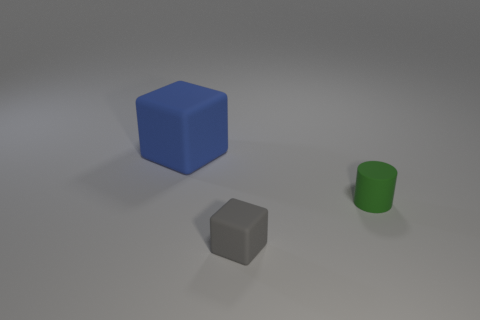Add 3 tiny gray things. How many objects exist? 6 Subtract all blocks. How many objects are left? 1 Add 2 large gray rubber cylinders. How many large gray rubber cylinders exist? 2 Subtract 1 gray blocks. How many objects are left? 2 Subtract all large blue objects. Subtract all small green objects. How many objects are left? 1 Add 1 green rubber objects. How many green rubber objects are left? 2 